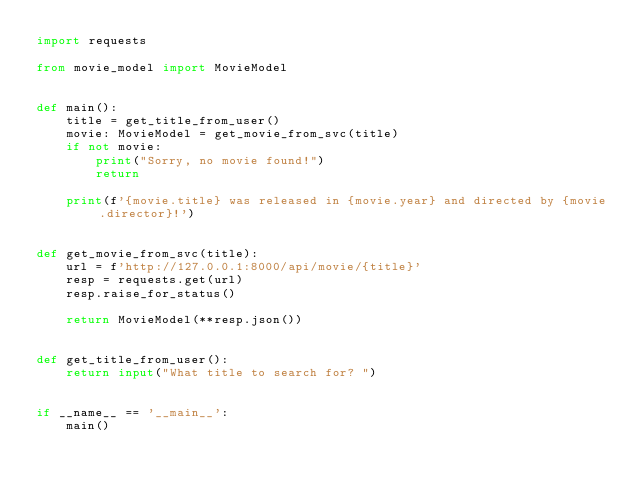Convert code to text. <code><loc_0><loc_0><loc_500><loc_500><_Python_>import requests

from movie_model import MovieModel


def main():
    title = get_title_from_user()
    movie: MovieModel = get_movie_from_svc(title)
    if not movie:
        print("Sorry, no movie found!")
        return

    print(f'{movie.title} was released in {movie.year} and directed by {movie.director}!')


def get_movie_from_svc(title):
    url = f'http://127.0.0.1:8000/api/movie/{title}'
    resp = requests.get(url)
    resp.raise_for_status()

    return MovieModel(**resp.json())


def get_title_from_user():
    return input("What title to search for? ")


if __name__ == '__main__':
    main()
</code> 